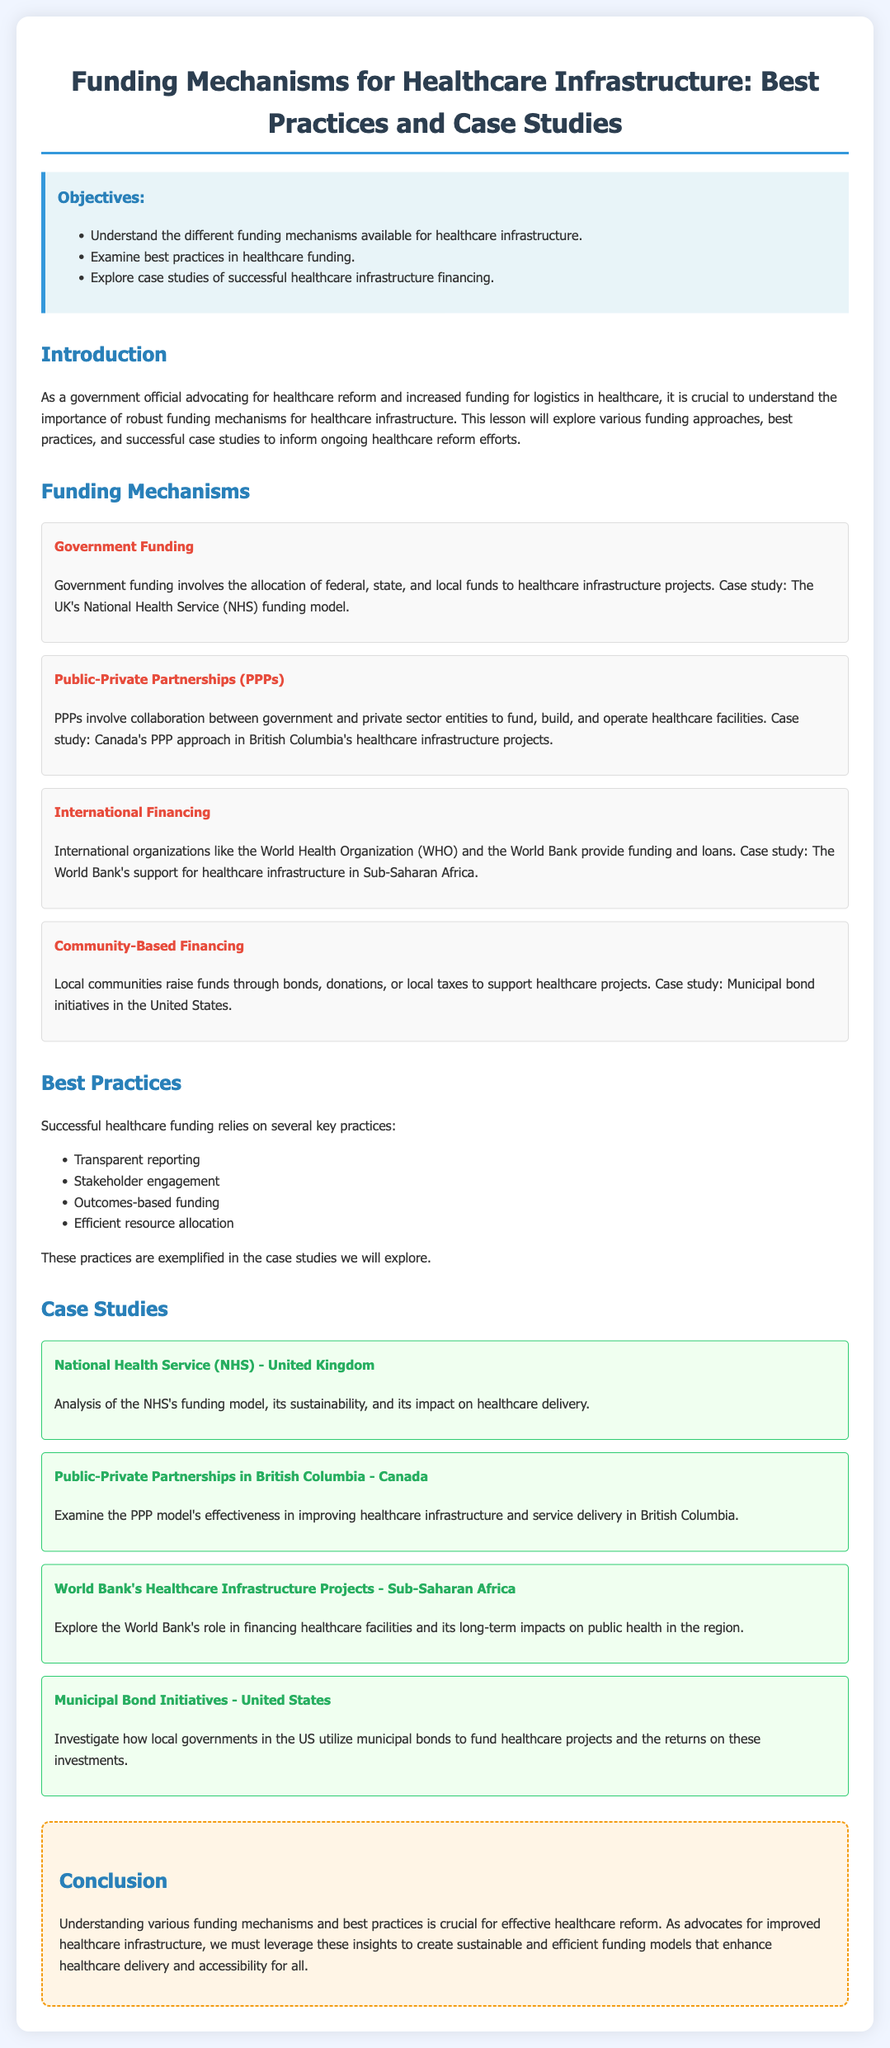What are the objectives of the lesson? The objectives outline the key goals of the lesson, which include understanding funding mechanisms, examining best practices, and exploring case studies.
Answer: Understand the different funding mechanisms available for healthcare infrastructure, examine best practices in healthcare funding, explore case studies of successful healthcare infrastructure financing What is one funding mechanism discussed in the document? The document lists several funding mechanisms for healthcare infrastructure, including government funding, PPPs, international financing, and community-based financing.
Answer: Government Funding Which case study examines the Healthcare Infrastructure in Sub-Saharan Africa? The case studies section details specific examples of healthcare infrastructure financing, including one that focuses on the World Bank's support in Sub-Saharan Africa.
Answer: World Bank's Healthcare Infrastructure Projects - Sub-Saharan Africa What funding model is referenced in the case study about British Columbia? The case study presents a specific example of collaboration between public and private sectors in British Columbia's healthcare projects.
Answer: Public-Private Partnerships in British Columbia What is a key practice for successful healthcare funding mentioned? The document identifies several best practices necessary for successful healthcare funding, with a focus on the importance of stakeholder engagement.
Answer: Stakeholder engagement How is the National Health Service (NHS) funding model characterized? The document provides an analysis of the NHS funding model, emphasizing its sustainability and impact on healthcare delivery.
Answer: Sustainability and impact on healthcare delivery What are the outcomes emphasized in the best practices for healthcare funding? The document discusses practices that ensure efficient use of resources and promote transparency in reporting healthcare funding outcomes.
Answer: Outcomes-based funding What type of lesson is this document categorized under? The document is formatted as a lesson plan, which includes objectives, funding mechanisms, best practices, case studies, and conclusions related to healthcare infrastructure funding.
Answer: Lesson plan 